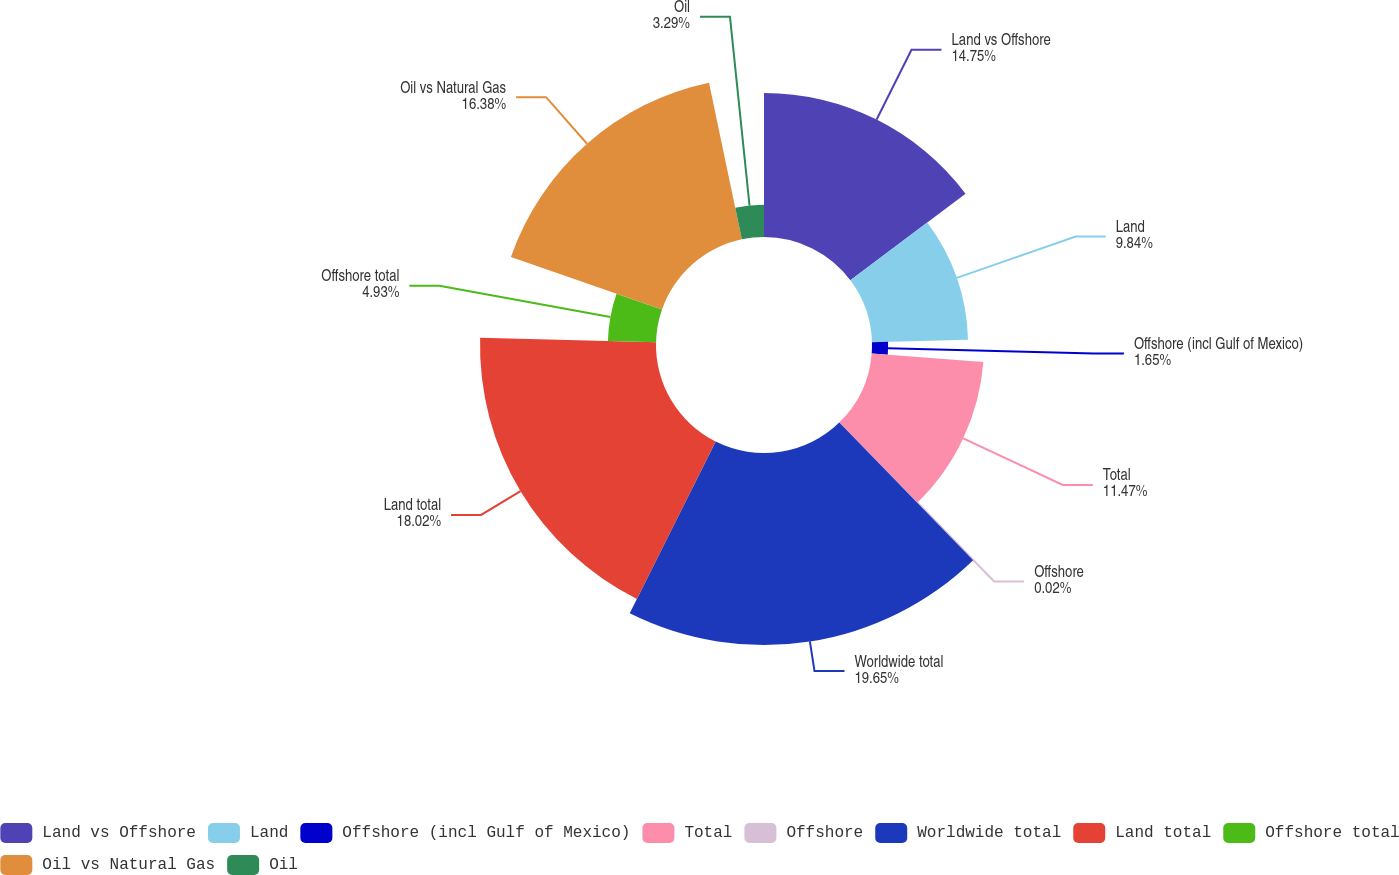<chart> <loc_0><loc_0><loc_500><loc_500><pie_chart><fcel>Land vs Offshore<fcel>Land<fcel>Offshore (incl Gulf of Mexico)<fcel>Total<fcel>Offshore<fcel>Worldwide total<fcel>Land total<fcel>Offshore total<fcel>Oil vs Natural Gas<fcel>Oil<nl><fcel>14.75%<fcel>9.84%<fcel>1.65%<fcel>11.47%<fcel>0.02%<fcel>19.66%<fcel>18.02%<fcel>4.93%<fcel>16.38%<fcel>3.29%<nl></chart> 